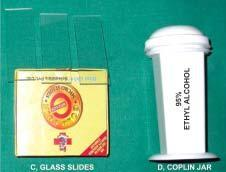what is equipments required for?
Answer the question using a single word or phrase. Transcutaneous fnac 